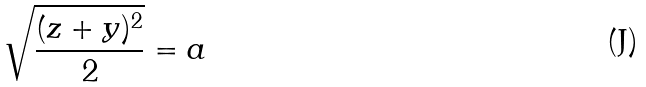<formula> <loc_0><loc_0><loc_500><loc_500>\sqrt { \frac { ( z + y ) ^ { 2 } } { 2 } } = a</formula> 